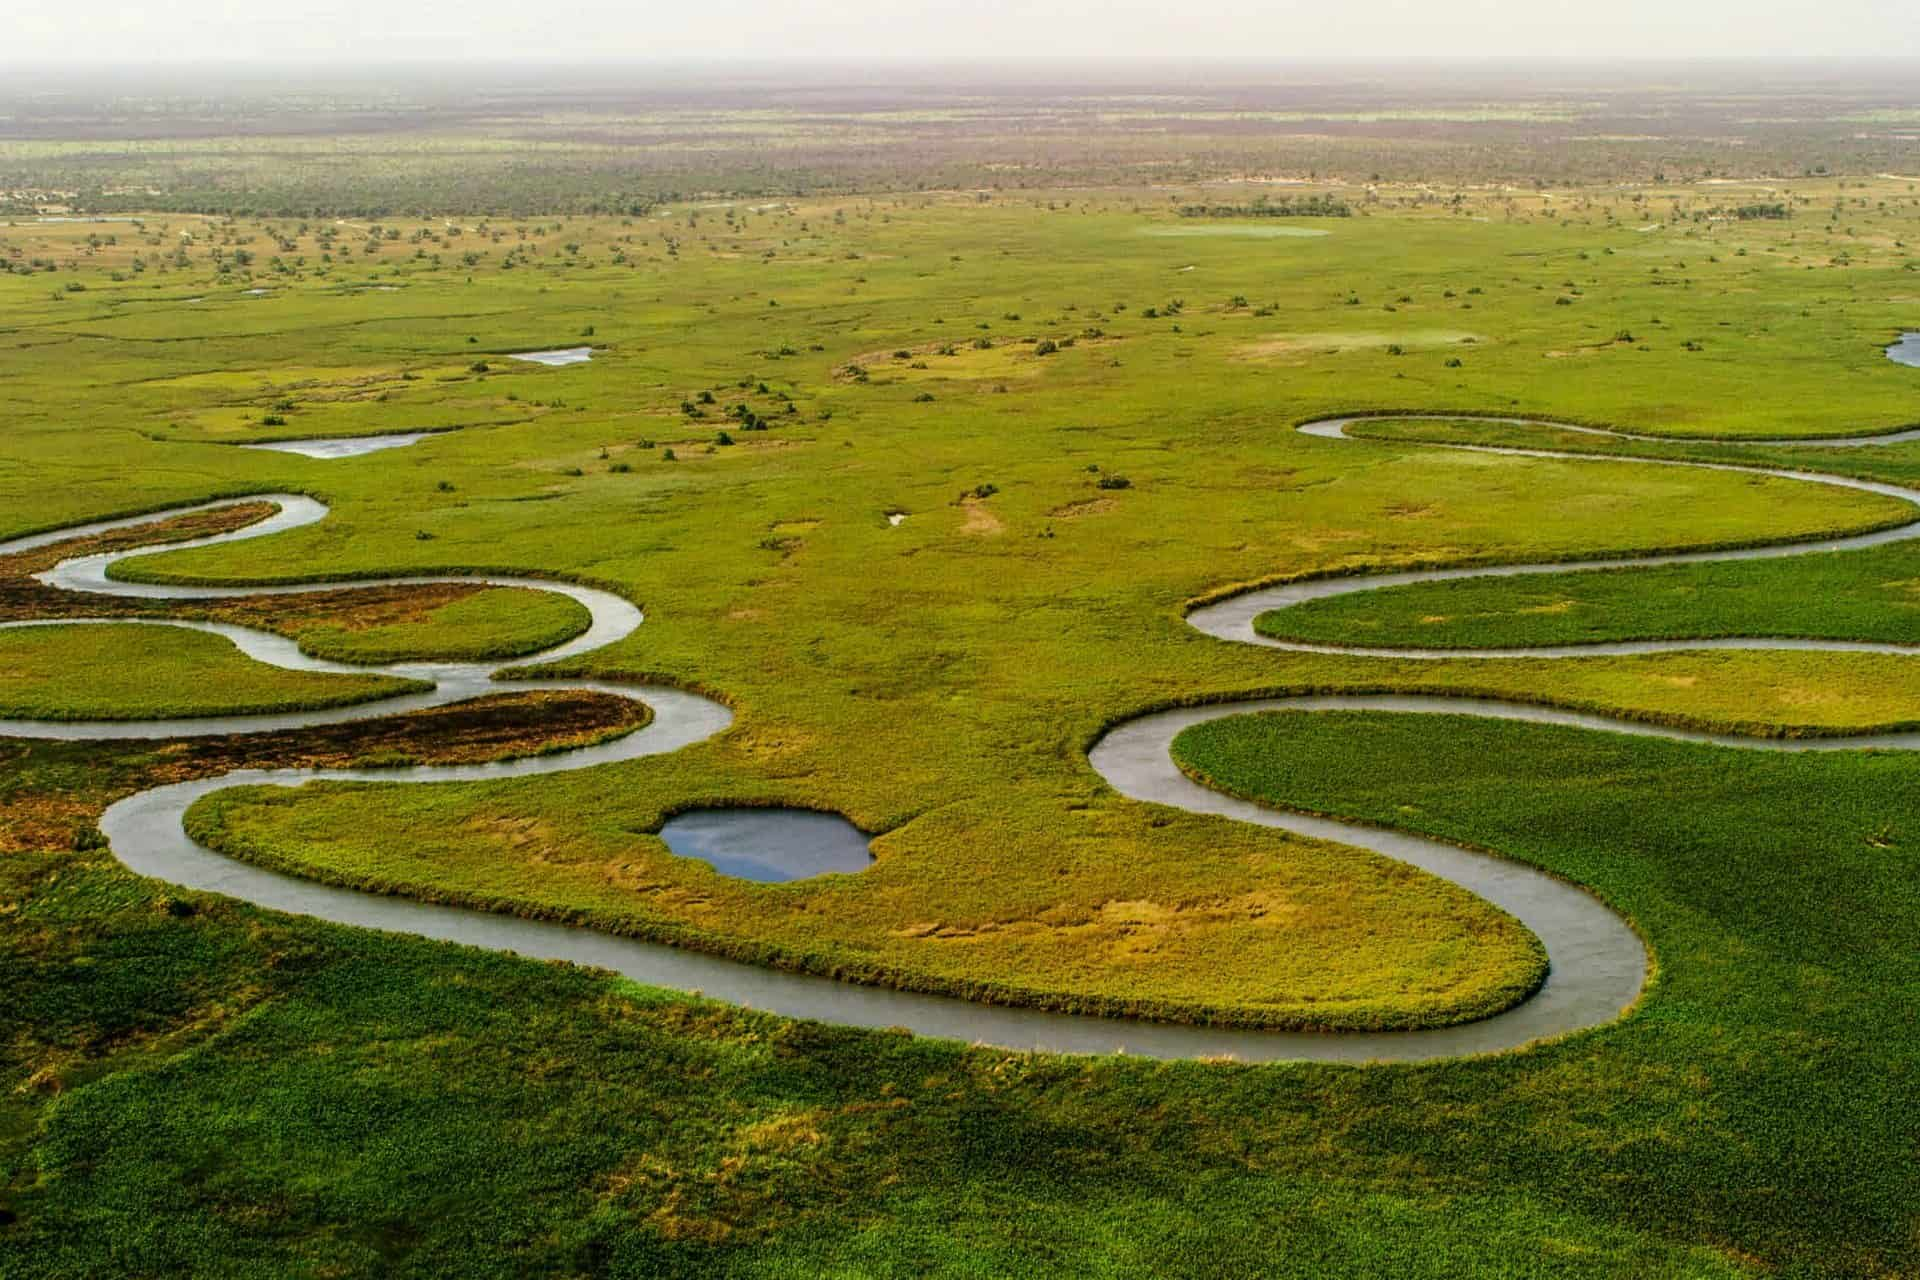Analyze the image in a comprehensive and detailed manner. The image showcases an aerial snapshot of the vast and biodiverse Okavango Delta in northern Botswana. Recognizing this region as one of the few delta systems that do not flow into the ocean, it spreads out into the Kalahari Desert sands creating an amazing and rare inland delta. The snaking channels and lush greenery teem with wildlife and vital ecosystems, sustaining a diverse array of animal species, from large mammals like elephants and lions to hundreds of bird species. The emerald green tones of the plant life, outlined by the meandering silvery waterways, stand in vivid contrast to the darker brown earth and occasional pools of water, which appear as scattered blue and aqua gems. This landscape is dynamic; its patterns shift with seasonal floods, and this flux sustains the complex web of life here. 